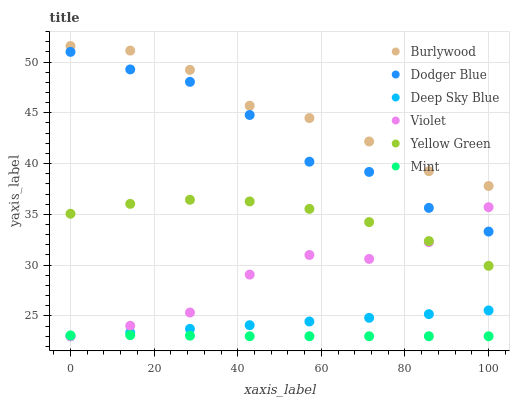Does Mint have the minimum area under the curve?
Answer yes or no. Yes. Does Burlywood have the maximum area under the curve?
Answer yes or no. Yes. Does Dodger Blue have the minimum area under the curve?
Answer yes or no. No. Does Dodger Blue have the maximum area under the curve?
Answer yes or no. No. Is Deep Sky Blue the smoothest?
Answer yes or no. Yes. Is Dodger Blue the roughest?
Answer yes or no. Yes. Is Burlywood the smoothest?
Answer yes or no. No. Is Burlywood the roughest?
Answer yes or no. No. Does Deep Sky Blue have the lowest value?
Answer yes or no. Yes. Does Dodger Blue have the lowest value?
Answer yes or no. No. Does Burlywood have the highest value?
Answer yes or no. Yes. Does Dodger Blue have the highest value?
Answer yes or no. No. Is Yellow Green less than Burlywood?
Answer yes or no. Yes. Is Dodger Blue greater than Mint?
Answer yes or no. Yes. Does Violet intersect Dodger Blue?
Answer yes or no. Yes. Is Violet less than Dodger Blue?
Answer yes or no. No. Is Violet greater than Dodger Blue?
Answer yes or no. No. Does Yellow Green intersect Burlywood?
Answer yes or no. No. 